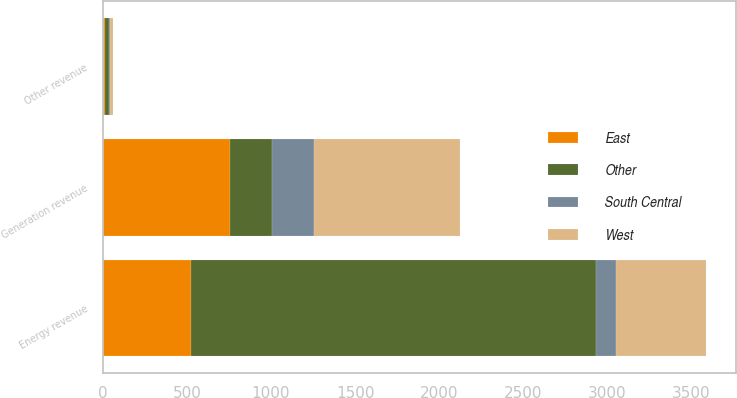<chart> <loc_0><loc_0><loc_500><loc_500><stacked_bar_chart><ecel><fcel>Energy revenue<fcel>Other revenue<fcel>Generation revenue<nl><fcel>Other<fcel>2406<fcel>28<fcel>249<nl><fcel>West<fcel>533<fcel>19<fcel>866<nl><fcel>East<fcel>527<fcel>10<fcel>757<nl><fcel>South Central<fcel>121<fcel>4<fcel>249<nl></chart> 